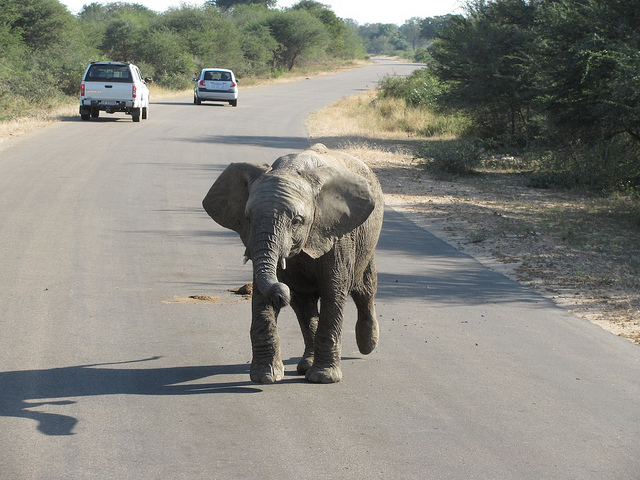Is the elephant going for a walk? Yes, the image depicts the elephant walking alone on what appears to be a paved road commonly used by vehicles. 